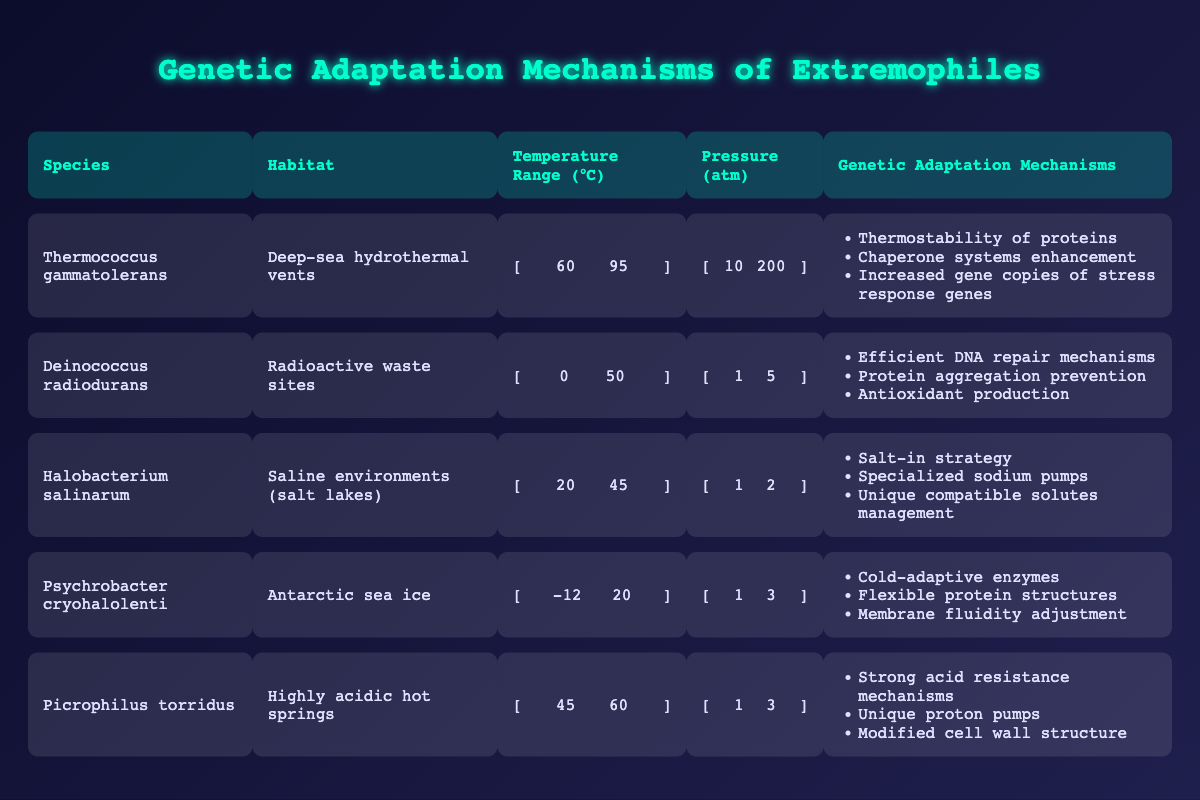What is the habitat of Thermococcus gammatolerans? The habitat is stated in the table under the "Habitat" column for the species Thermococcus gammatolerans, which shows "Deep-sea hydrothermal vents"
Answer: Deep-sea hydrothermal vents Which extremophile has the highest temperature range? By comparing the temperature ranges in the table, Thermococcus gammatolerans has a range of 60 to 95 degrees Celsius, higher than others.
Answer: Thermococcus gammatolerans Do all extremophiles listed have genetic adaptation mechanisms related to protein stability? Reviewing the "Genetic Adaptation Mechanisms" column, it's clear that not all mechanisms are related to protein stability— for example, Halobacterium salinarum includes "Specialized sodium pumps," which does not focus on protein stability.
Answer: No What is the average pressure range of the extremophiles in the table? To find the average pressure, sum up the lower and upper limits: (10 + 200 + 1 + 5 + 1 + 2 + 1 + 3 + 1 + 3) = 227 and (200 + 5 + 2 + 3 + 3) = 213. The average of the lower limit is 227 / 5 = 45.4 and for the upper limit is 213 / 5 = 42.6
Answer: Lower: 45.4 atm, Upper: 42.6 atm Does the species Psychrobacter cryohalolenti have mechanisms for cold adaptation? The "Genetic Adaptation Mechanisms" for Psychrobacter cryohalolenti include "Cold-adaptive enzymes," which confirms its adaptations to cold environments.
Answer: Yes How many total different genetic adaptation mechanisms are present in Picrophilus torridus? The table indicates that Picrophilus torridus has three listed mechanisms: Strong acid resistance mechanisms, Unique proton pumps, and Modified cell wall structure. Thus, the total count is three.
Answer: 3 Which organism demonstrates both a high resistance to temperature and pressure extremes? According to the table, Thermococcus gammatolerans has a high-temperature range (60-95 °C) and a high pressure range (10-200 atm), indicating significant resistance to both extremes.
Answer: Thermococcus gammatolerans What types of environments does Halobacterium salinarum inhabit according to the table? The table clearly categorizes Halobacterium salinarum's habitat as "Saline environments (salt lakes)," showing its adaptation to high salt concentrations
Answer: Saline environments (salt lakes) Which extremophile undergoes adaptations due to high acidity according to its genetic mechanisms? Picrophilus torridus is specifically noted for "Strong acid resistance mechanisms," highlighting its adaptations to acidic environments.
Answer: Picrophilus torridus 